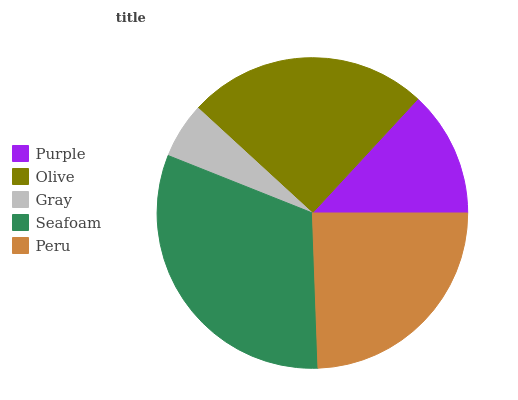Is Gray the minimum?
Answer yes or no. Yes. Is Seafoam the maximum?
Answer yes or no. Yes. Is Olive the minimum?
Answer yes or no. No. Is Olive the maximum?
Answer yes or no. No. Is Olive greater than Purple?
Answer yes or no. Yes. Is Purple less than Olive?
Answer yes or no. Yes. Is Purple greater than Olive?
Answer yes or no. No. Is Olive less than Purple?
Answer yes or no. No. Is Peru the high median?
Answer yes or no. Yes. Is Peru the low median?
Answer yes or no. Yes. Is Olive the high median?
Answer yes or no. No. Is Olive the low median?
Answer yes or no. No. 